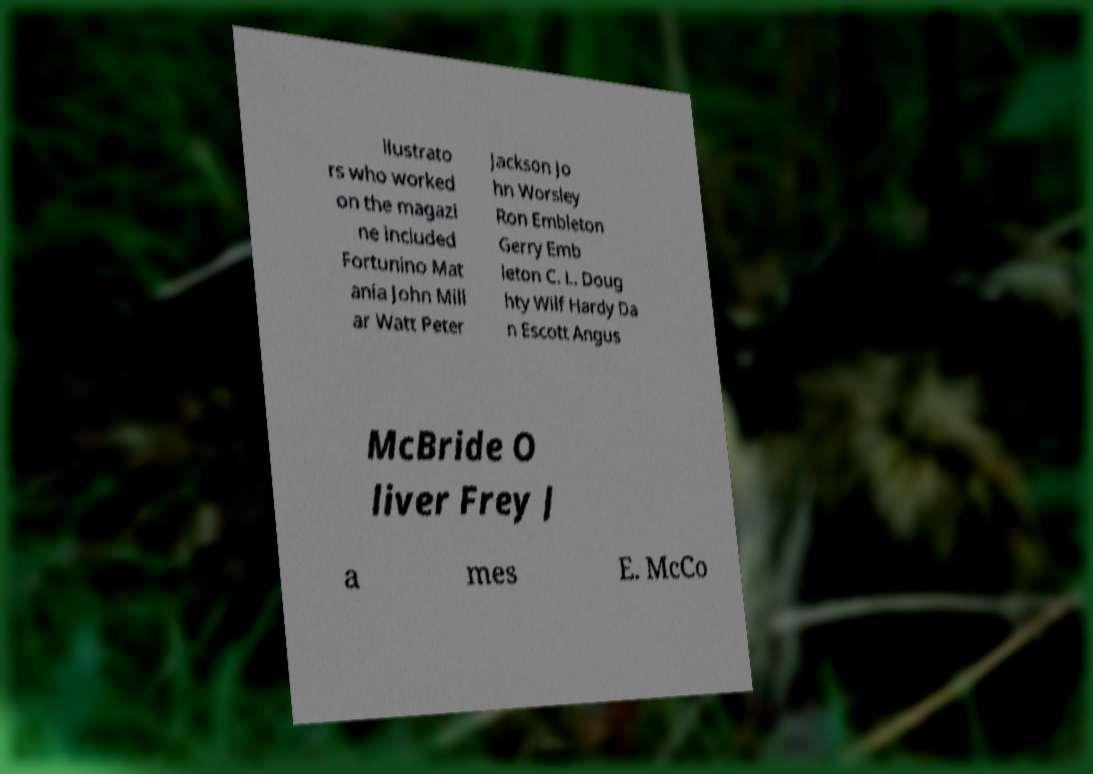Can you read and provide the text displayed in the image?This photo seems to have some interesting text. Can you extract and type it out for me? llustrato rs who worked on the magazi ne included Fortunino Mat ania John Mill ar Watt Peter Jackson Jo hn Worsley Ron Embleton Gerry Emb leton C. L. Doug hty Wilf Hardy Da n Escott Angus McBride O liver Frey J a mes E. McCo 